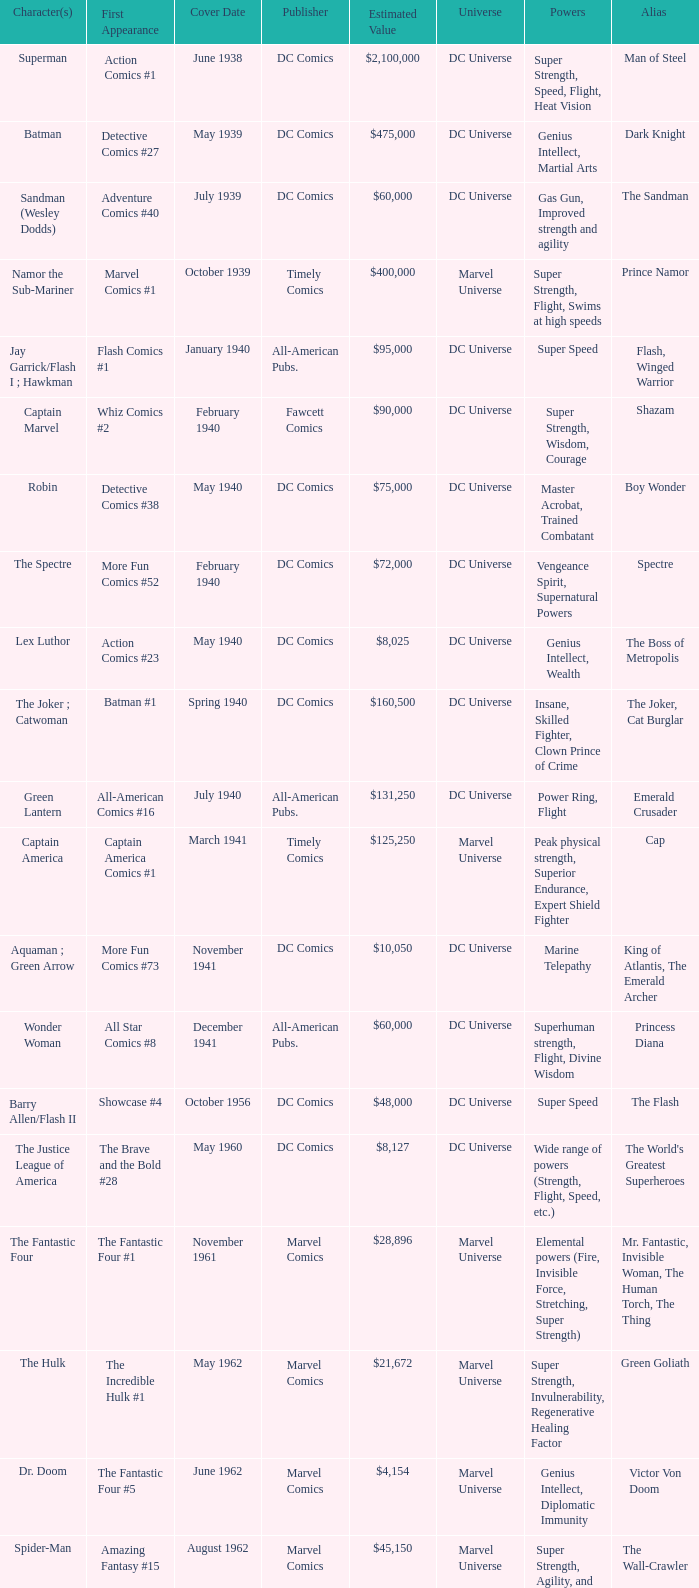What is Action Comics #1's estimated value? $2,100,000. 